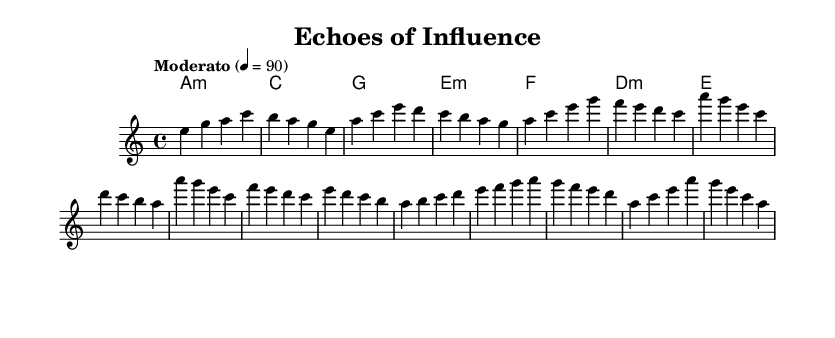What is the key signature of this music? The key signature shown in the sheet music has one flat, indicating it is in A minor.
Answer: A minor What is the time signature of this music? The time signature appears at the beginning of the score, indicating a 4/4 meter, which means there are four beats per measure.
Answer: 4/4 What is the tempo marking of this music? The tempo marking is specified as "Moderato" with a tempo of 90 beats per minute, as indicated in the score.
Answer: Moderato How many measures are there in the melody? By counting the groups of vertical lines in the melody section, there are a total of 16 measures.
Answer: 16 Which section features a bridge? In the structure of the piece, the section labeled as "Bridge" contains the bridge, which distinguishes it from the other parts of the score.
Answer: Bridge What is the first note of the melody? Looking at the beginning of the melody, the very first note that appears is E.
Answer: E What chord follows the first measure of melody? The chord that follows the first measure of melody is indicated as A minor, denoted by the first chord above the melody line.
Answer: A minor 